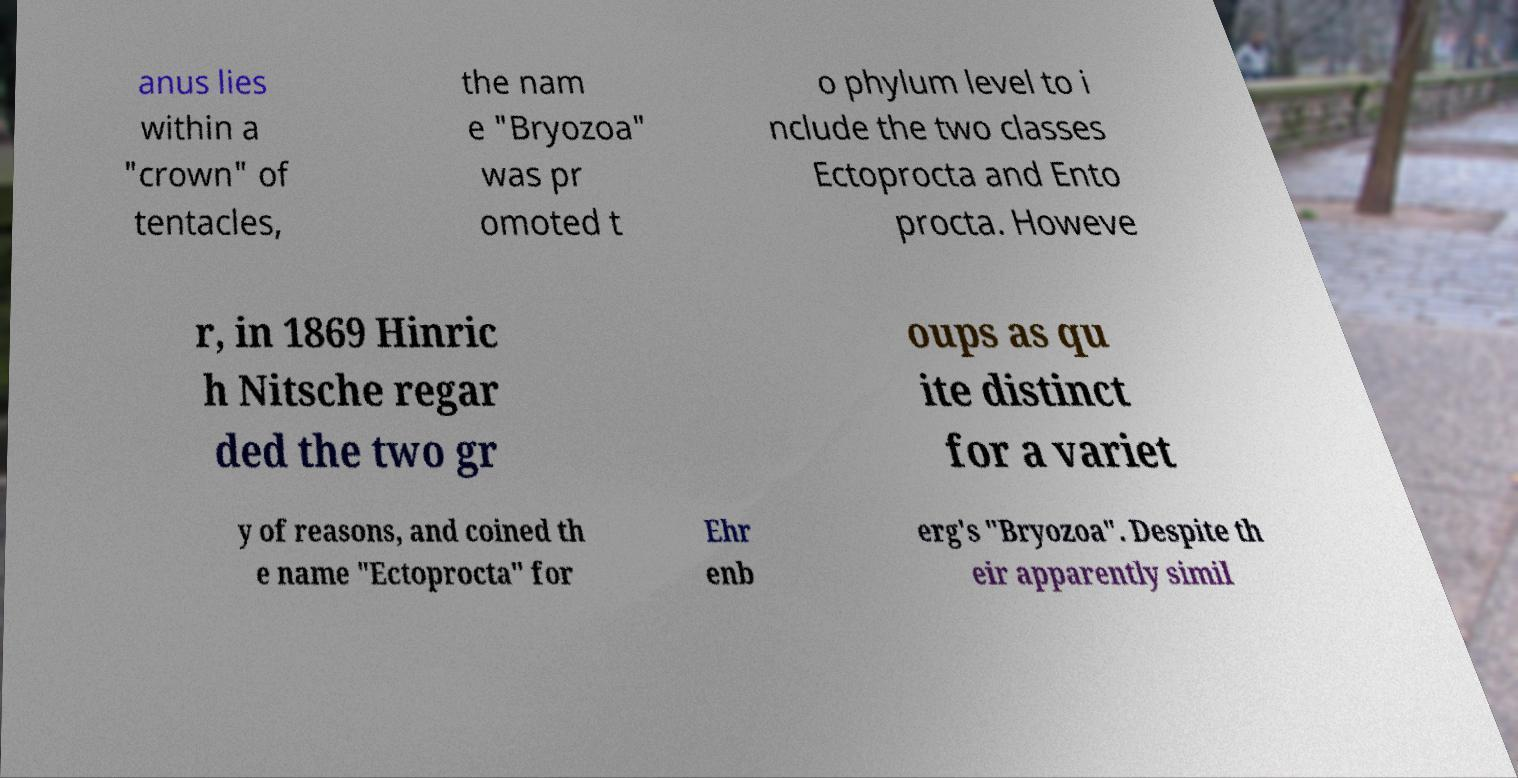I need the written content from this picture converted into text. Can you do that? anus lies within a "crown" of tentacles, the nam e "Bryozoa" was pr omoted t o phylum level to i nclude the two classes Ectoprocta and Ento procta. Howeve r, in 1869 Hinric h Nitsche regar ded the two gr oups as qu ite distinct for a variet y of reasons, and coined th e name "Ectoprocta" for Ehr enb erg's "Bryozoa". Despite th eir apparently simil 